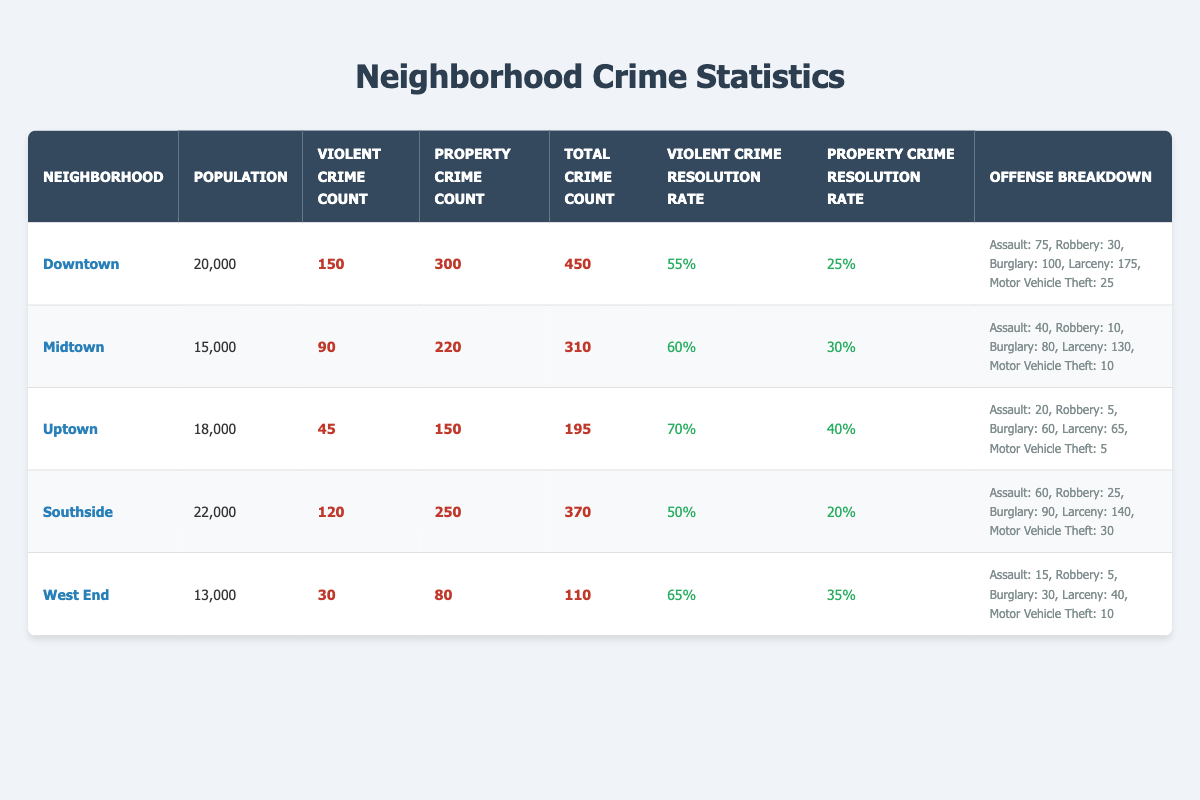What is the total number of violent crimes reported in Downtown? From the table, the Violent Crime Count for Downtown is listed as 150.
Answer: 150 What is the property crime resolution rate in Uptown? The Property Crime Resolution Rate for Uptown is provided in the table as 40%.
Answer: 40% Which neighborhood has the highest total crime count? By comparing the Total Crime Count values, Downtown has the highest at 450, followed by Southside at 370.
Answer: Downtown What is the average population of all neighborhoods listed? The population values are 20,000 (Downtown), 15,000 (Midtown), 18,000 (Uptown), 22,000 (Southside), and 13,000 (West End). Summing these gives 108,000. Dividing by 5 neighborhoods gives an average of 21,600.
Answer: 21,600 Which neighborhood has a higher resolution rate for violent crimes: Midtown or Southside? Midtown has a Violent Crime Resolution Rate of 60%, while Southside's is 50%. Therefore, Midtown has the higher rate.
Answer: Midtown What is the difference between the total crime counts of Downtown and West End? The Total Crime Count for Downtown is 450 and for West End is 110. Subtracting these gives 450 - 110 = 340.
Answer: 340 Is the property crime resolution rate in Southside higher than that in Downtown? Southside has a Property Crime Resolution Rate of 20%, while Downtown's is 25%. Since 20% is not higher than 25%, the answer is no.
Answer: No How many property crimes were reported in Midtown? From the table, the Property Crime Count for Midtown is indicated as 220.
Answer: 220 What is the combined total of all the assault offenses across all neighborhoods? The assault offenses are 75 (Downtown), 40 (Midtown), 20 (Uptown), 60 (Southside), and 15 (West End). Summing these gives 75 + 40 + 20 + 60 + 15 = 210.
Answer: 210 Which neighborhood has the lowest property crime resolution rate? From the table, comparing the rates, Southside has the lowest Property Crime Resolution Rate at 20%.
Answer: Southside 